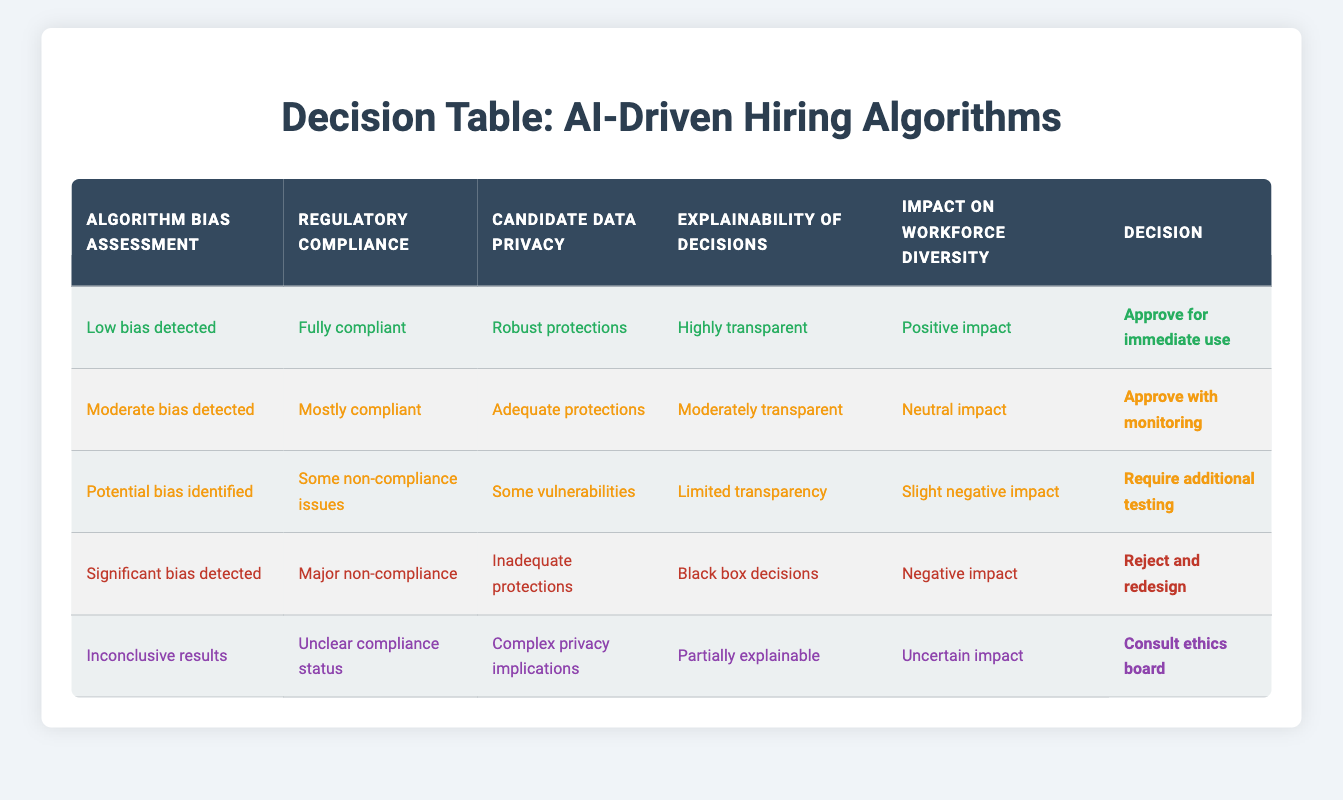What decision is made when no bias is detected? The table indicates that when the algorithm bias assessment shows "Low bias detected," along with regulatory compliance being "Fully compliant," and other positive indicators, the decision is to "Approve for immediate use."
Answer: Approve for immediate use How many decisions involve monitoring? There are two rows where the decision states "Approve with monitoring" and "Require additional testing." The monitoring is specifically mentioned in the second row regarding "Moderate bias detected."
Answer: 2 Is there any situation where the candidate data privacy is noted as inadequate? Yes, in the fourth rule it explicitly states "Inadequate protections" under the column for candidate data privacy, which corresponds to a significant bias detected and major non-compliance.
Answer: Yes If the algorithm shows significant bias, what is the required action? According to the table, if the assessment identifies "Significant bias detected," the decision made is to "Reject and redesign." Thus, any significant bias leads to this specific action.
Answer: Reject and redesign What is the impact on workforce diversity for a decision to consult the ethics board? The row for the decision "Consult ethics board" shows an "Uncertain impact" on workforce diversity. This implies that there are thresholds or concerns that prevent a clear determination of the algorithm's effect on workforce diversity.
Answer: Uncertain impact What decision is made when there are complex privacy implications? The action that should be taken in a scenario where "Candidate data privacy" is deemed to have "Complex privacy implications" is to "Consult ethics board." This highlights the need for further ethical scrutiny regarding the algorithm’s design.
Answer: Consult ethics board Are the algorithms approved for immediate use in cases where there are moderate compliance issues? No, the table indicates that if the regulatory compliance is "Mostly compliant," the decision made is to "Approve with monitoring," not immediate use. Thus, moderate compliance issues prevent immediate approval.
Answer: No How many rows indicate a positive impact on workforce diversity? Only one row indicates a "Positive impact," which corresponds to the lowest bias detection and full compliance. Therefore, there is a single row with this classification while others either indicate neutral or negative impacts.
Answer: 1 